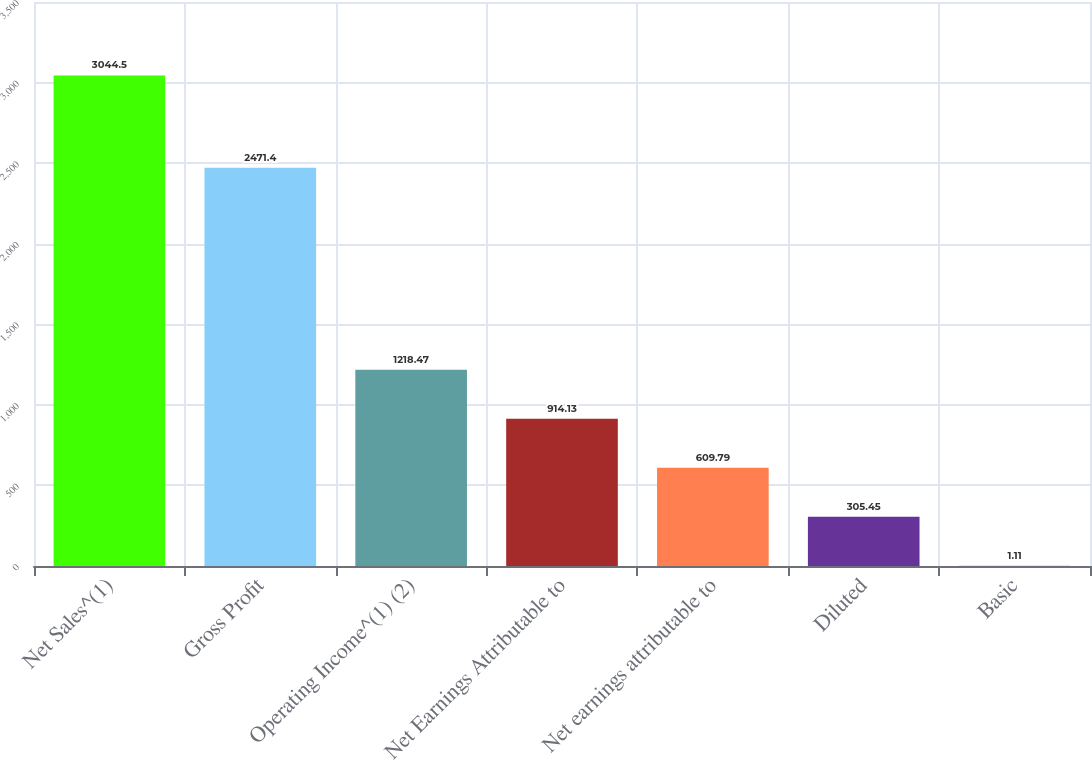Convert chart. <chart><loc_0><loc_0><loc_500><loc_500><bar_chart><fcel>Net Sales^(1)<fcel>Gross Profit<fcel>Operating Income^(1) (2)<fcel>Net Earnings Attributable to<fcel>Net earnings attributable to<fcel>Diluted<fcel>Basic<nl><fcel>3044.5<fcel>2471.4<fcel>1218.47<fcel>914.13<fcel>609.79<fcel>305.45<fcel>1.11<nl></chart> 